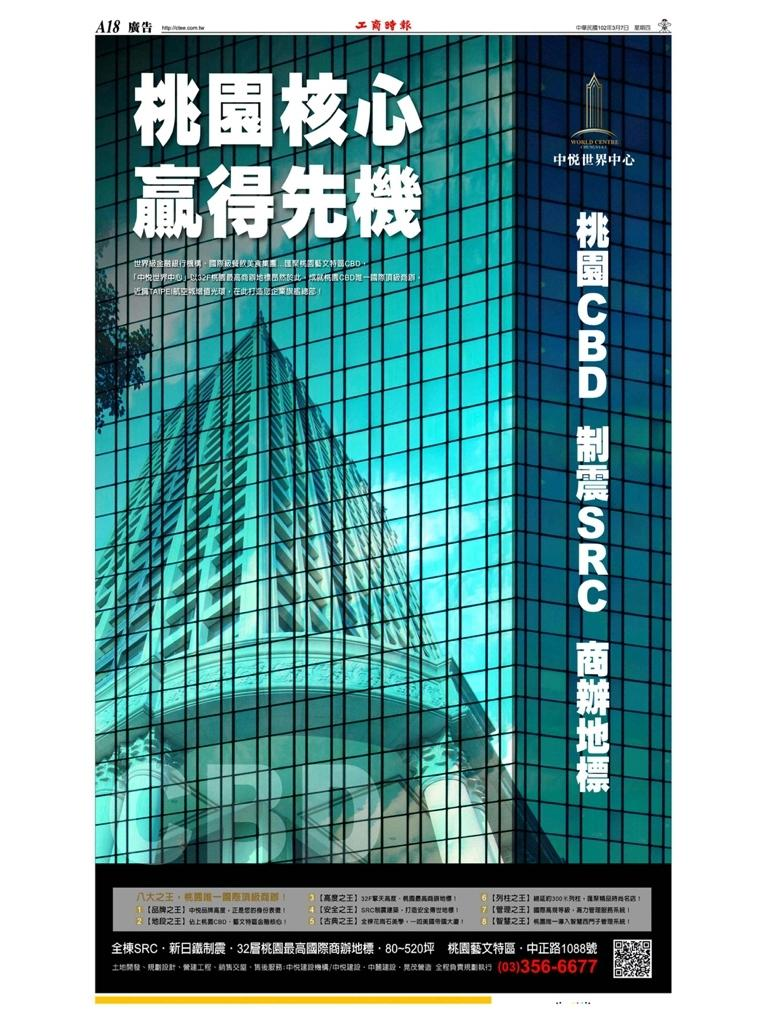What can be found in the foreground of the poster? There is text in the foreground of the poster. What type of structure is depicted in the poster? There is a building depicted in the poster. What can be seen in the sky in the poster? There are clouds visible in the poster. What is the background of the poster? The sky is present in the poster. What type of vegetation is in the poster? There is a tree in the poster. What type of soup is being served at the birthday party in the poster? There is no birthday party or soup depicted in the poster; it features text, a building, clouds, the sky, and a tree. 